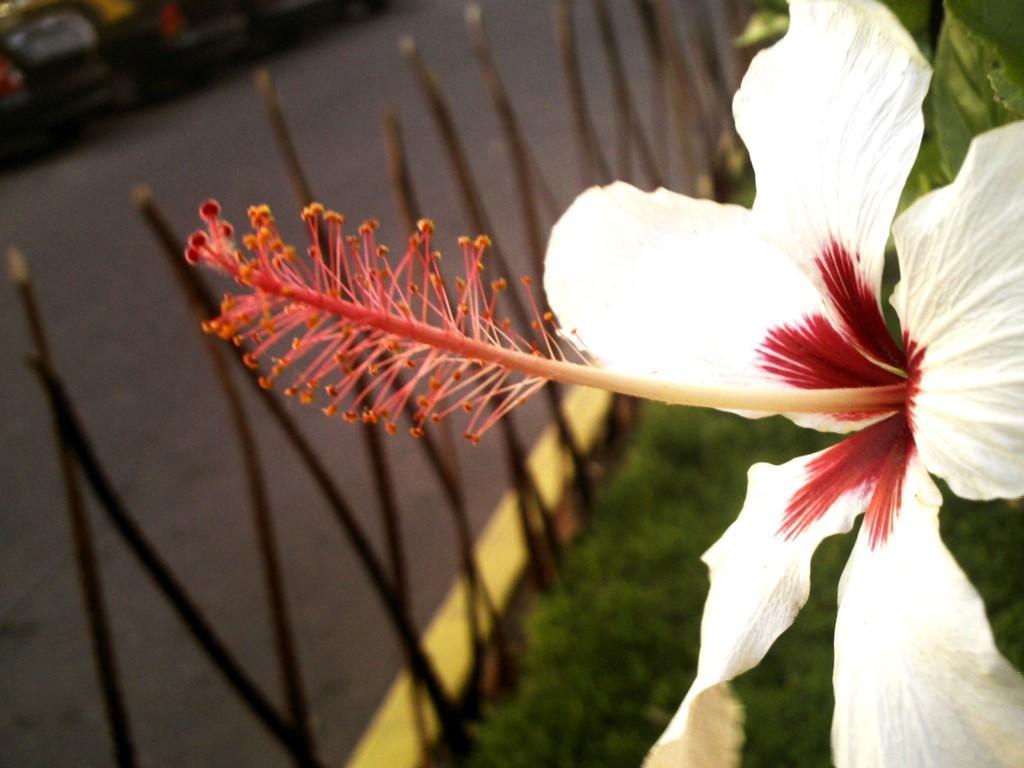Could you give a brief overview of what you see in this image? In the foreground of the picture there is a flower. The background is blurred. In the background there are grass, railing, road and autos. 